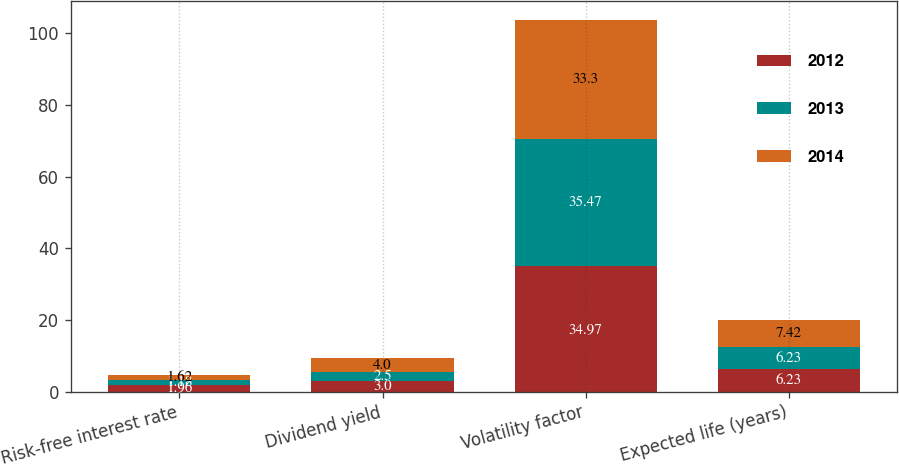Convert chart to OTSL. <chart><loc_0><loc_0><loc_500><loc_500><stacked_bar_chart><ecel><fcel>Risk-free interest rate<fcel>Dividend yield<fcel>Volatility factor<fcel>Expected life (years)<nl><fcel>2012<fcel>1.96<fcel>3<fcel>34.97<fcel>6.23<nl><fcel>2013<fcel>1.18<fcel>2.5<fcel>35.47<fcel>6.23<nl><fcel>2014<fcel>1.62<fcel>4<fcel>33.3<fcel>7.42<nl></chart> 